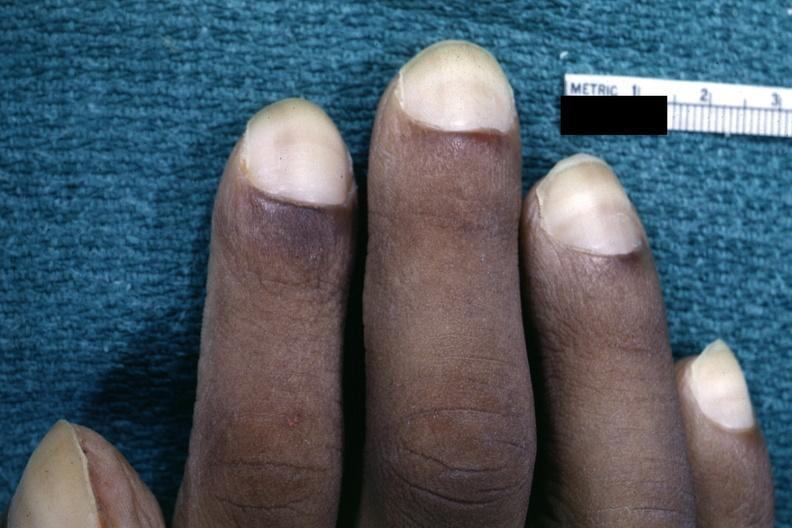what is present?
Answer the question using a single word or phrase. Hand 